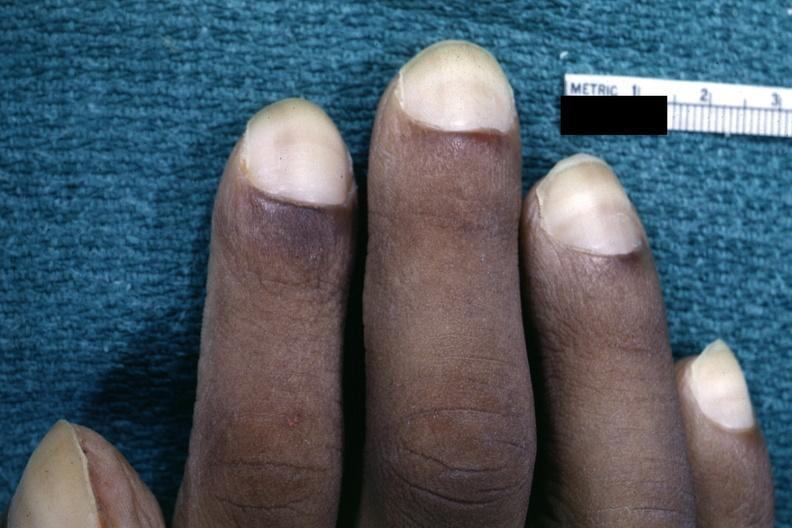what is present?
Answer the question using a single word or phrase. Hand 